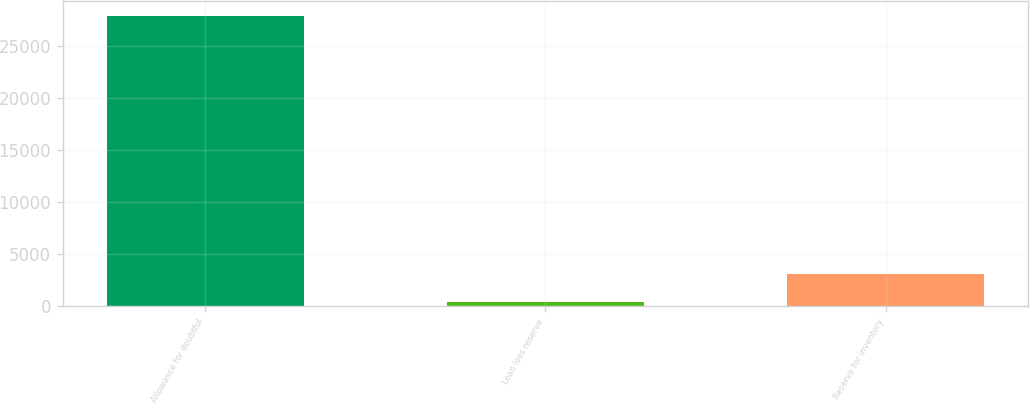<chart> <loc_0><loc_0><loc_500><loc_500><bar_chart><fcel>Allowance for doubtful<fcel>Loan loss reserve<fcel>Reserve for inventory<nl><fcel>27853<fcel>346<fcel>3096.7<nl></chart> 